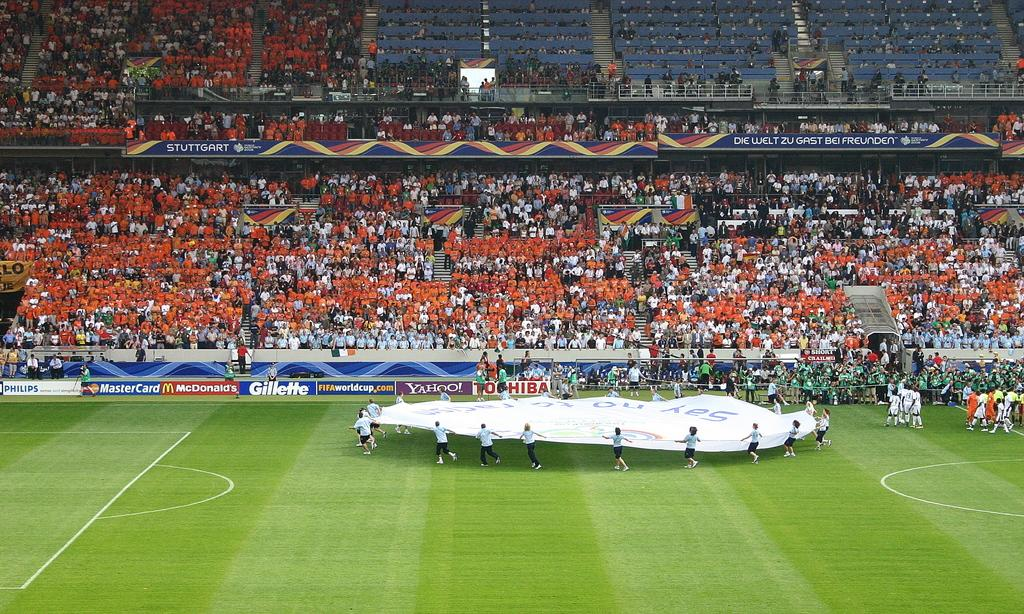<image>
Summarize the visual content of the image. Several people hold a large round piece of cloth in front of ads for Gillette and Toshiba. 